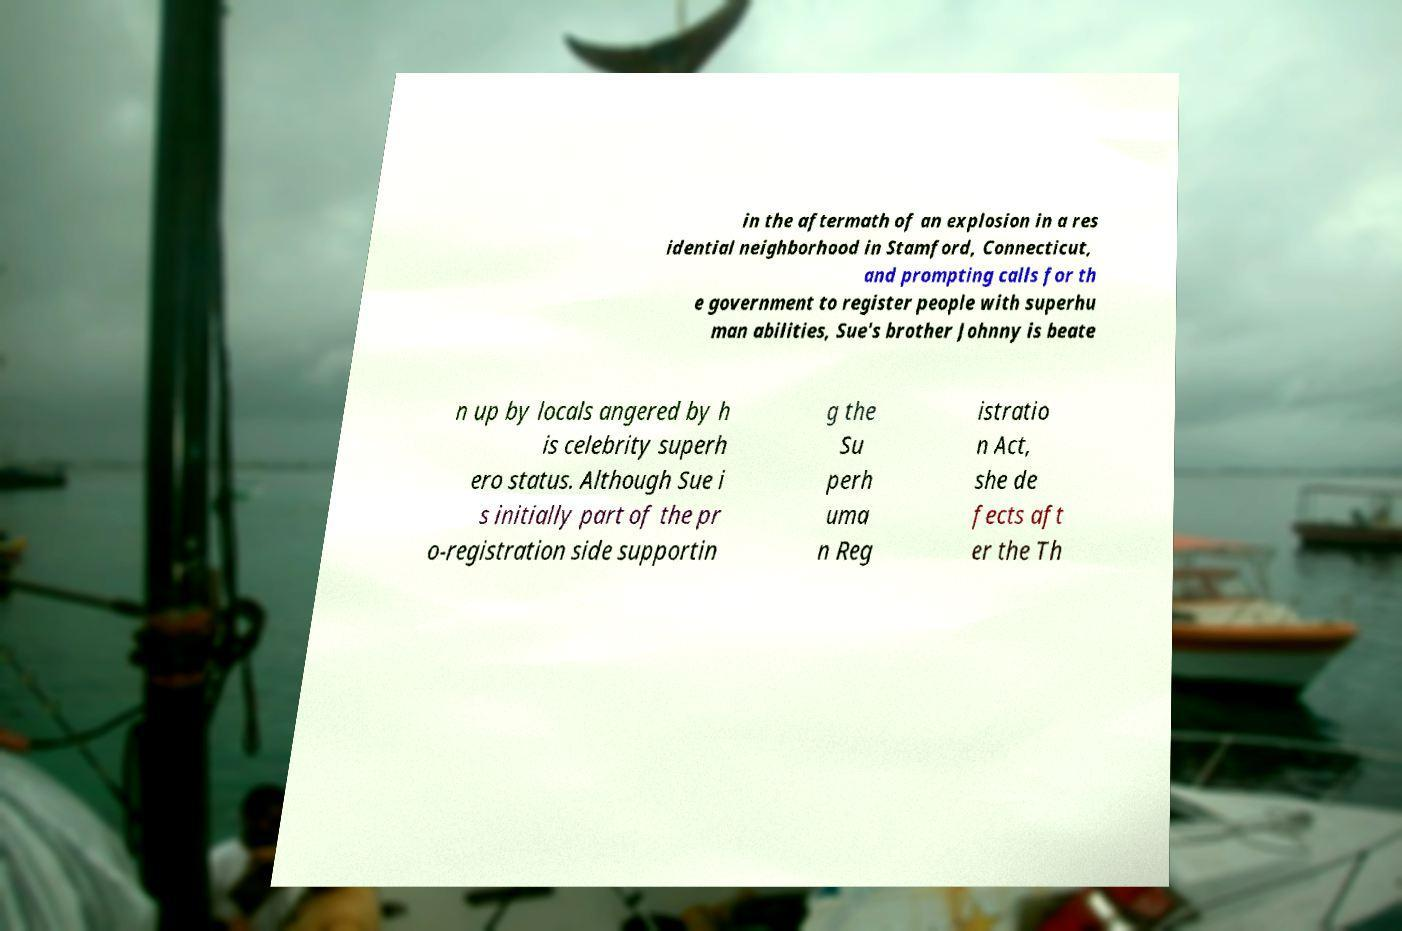Please read and relay the text visible in this image. What does it say? in the aftermath of an explosion in a res idential neighborhood in Stamford, Connecticut, and prompting calls for th e government to register people with superhu man abilities, Sue's brother Johnny is beate n up by locals angered by h is celebrity superh ero status. Although Sue i s initially part of the pr o-registration side supportin g the Su perh uma n Reg istratio n Act, she de fects aft er the Th 